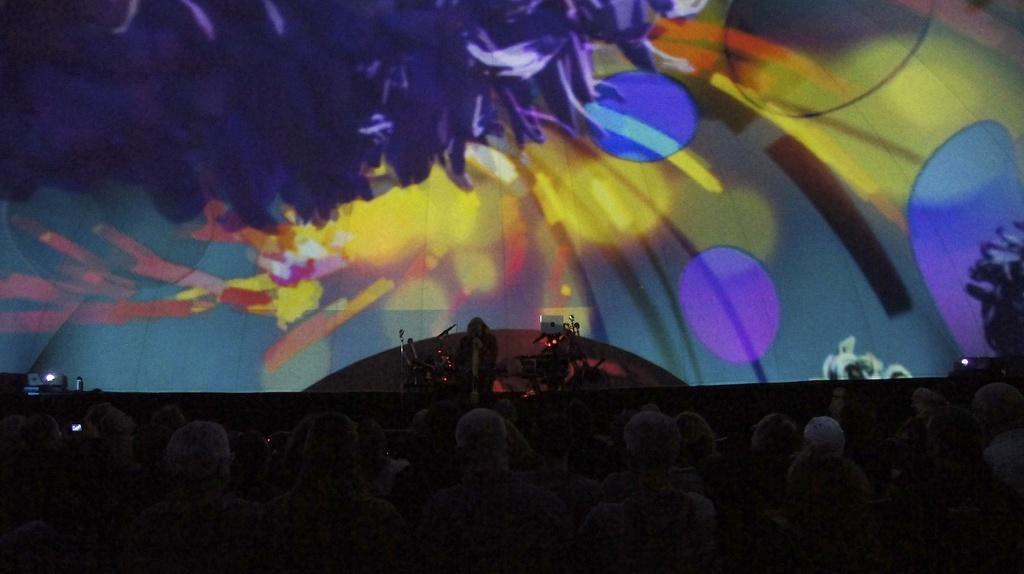What is the main feature of the image? There is a stage in the image. Who or what is on the stage? There is a person on the stage. What else can be seen in the image related to the stage? There are musical instruments in the image. What is happening at the bottom of the stage? There are people standing at the bottom of the stage. What type of trousers is the creature wearing in the image? There is no creature present in the image, and therefore no trousers can be observed. 